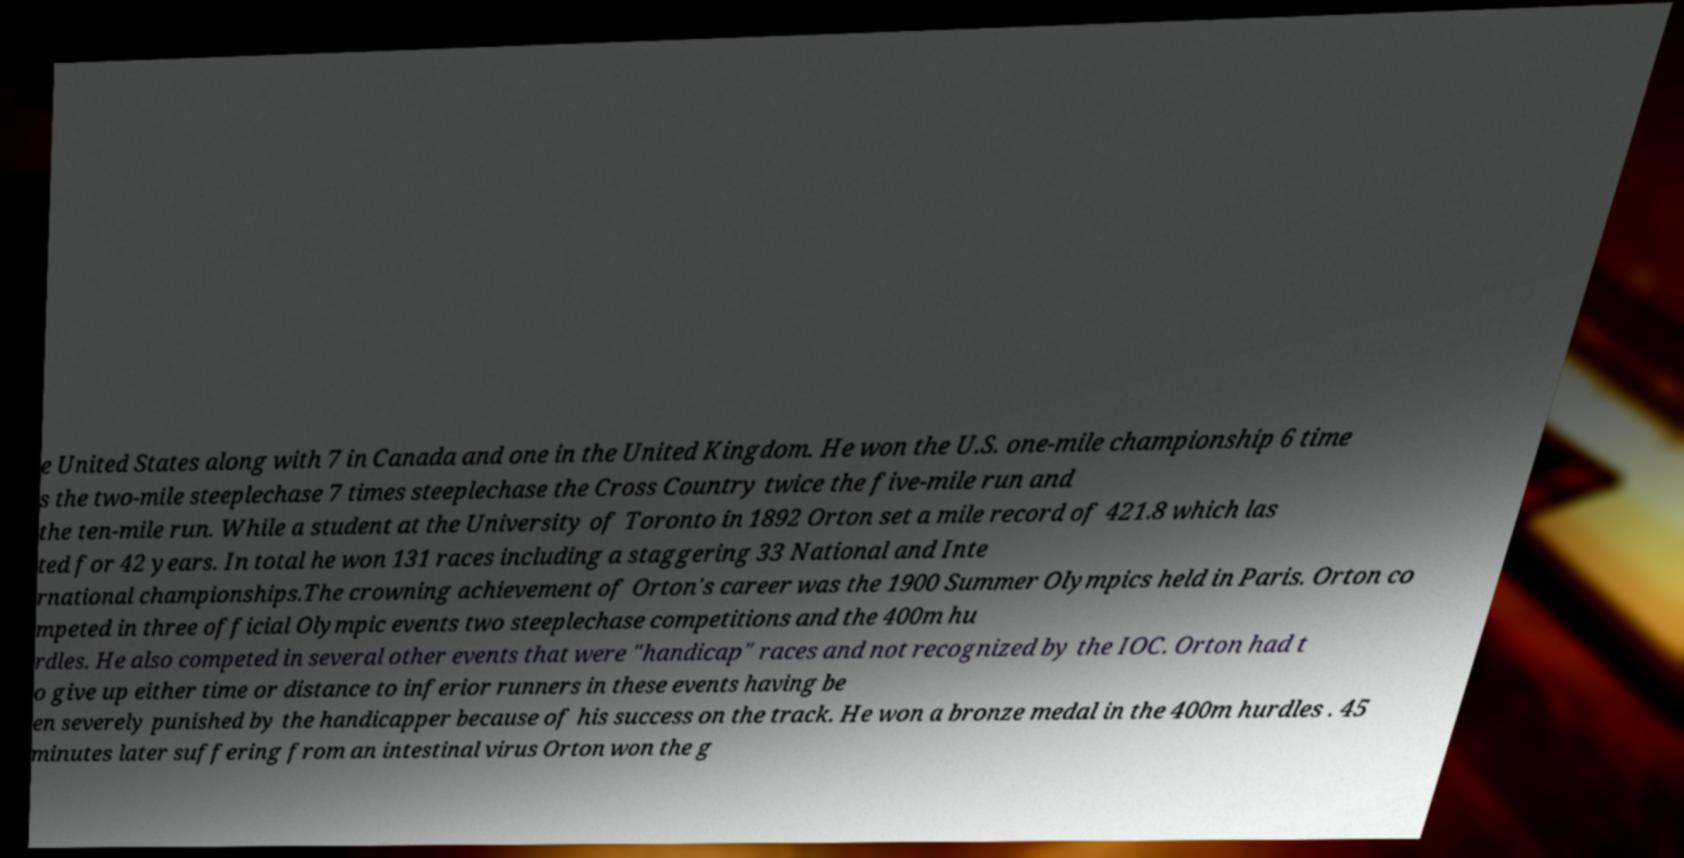Please identify and transcribe the text found in this image. e United States along with 7 in Canada and one in the United Kingdom. He won the U.S. one-mile championship 6 time s the two-mile steeplechase 7 times steeplechase the Cross Country twice the five-mile run and the ten-mile run. While a student at the University of Toronto in 1892 Orton set a mile record of 421.8 which las ted for 42 years. In total he won 131 races including a staggering 33 National and Inte rnational championships.The crowning achievement of Orton's career was the 1900 Summer Olympics held in Paris. Orton co mpeted in three official Olympic events two steeplechase competitions and the 400m hu rdles. He also competed in several other events that were "handicap" races and not recognized by the IOC. Orton had t o give up either time or distance to inferior runners in these events having be en severely punished by the handicapper because of his success on the track. He won a bronze medal in the 400m hurdles . 45 minutes later suffering from an intestinal virus Orton won the g 